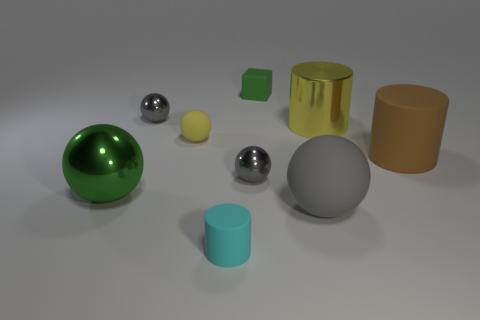The cylinder that is right of the big metal object that is behind the yellow thing to the left of the green matte thing is made of what material?
Your response must be concise. Rubber. What shape is the cyan thing that is the same size as the yellow rubber ball?
Your response must be concise. Cylinder. What number of objects are big purple metal spheres or big gray things that are in front of the big metallic ball?
Give a very brief answer. 1. Is the material of the large sphere that is in front of the large metal sphere the same as the big object that is left of the small rubber sphere?
Offer a very short reply. No. The tiny rubber object that is the same color as the metallic cylinder is what shape?
Give a very brief answer. Sphere. How many yellow things are large things or large metal cubes?
Your response must be concise. 1. The yellow cylinder has what size?
Your response must be concise. Large. Is the number of big gray rubber spheres behind the large brown matte cylinder greater than the number of brown matte blocks?
Offer a very short reply. No. What number of small things are behind the yellow rubber object?
Give a very brief answer. 2. Are there any yellow spheres that have the same size as the brown cylinder?
Keep it short and to the point. No. 